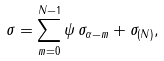<formula> <loc_0><loc_0><loc_500><loc_500>\sigma = \sum _ { m = 0 } ^ { N - 1 } \psi \, \sigma _ { \alpha - m } + \sigma _ { ( N ) } ,</formula> 